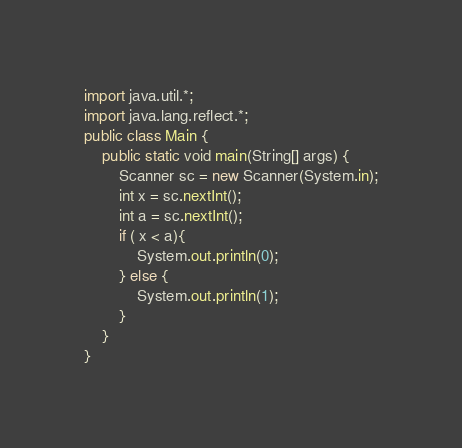Convert code to text. <code><loc_0><loc_0><loc_500><loc_500><_Java_>import java.util.*;
import java.lang.reflect.*;
public class Main {
    public static void main(String[] args) {
        Scanner sc = new Scanner(System.in);
        int x = sc.nextInt();
        int a = sc.nextInt();
        if ( x < a){
            System.out.println(0);
        } else {
            System.out.println(1);
        }
    }
}</code> 